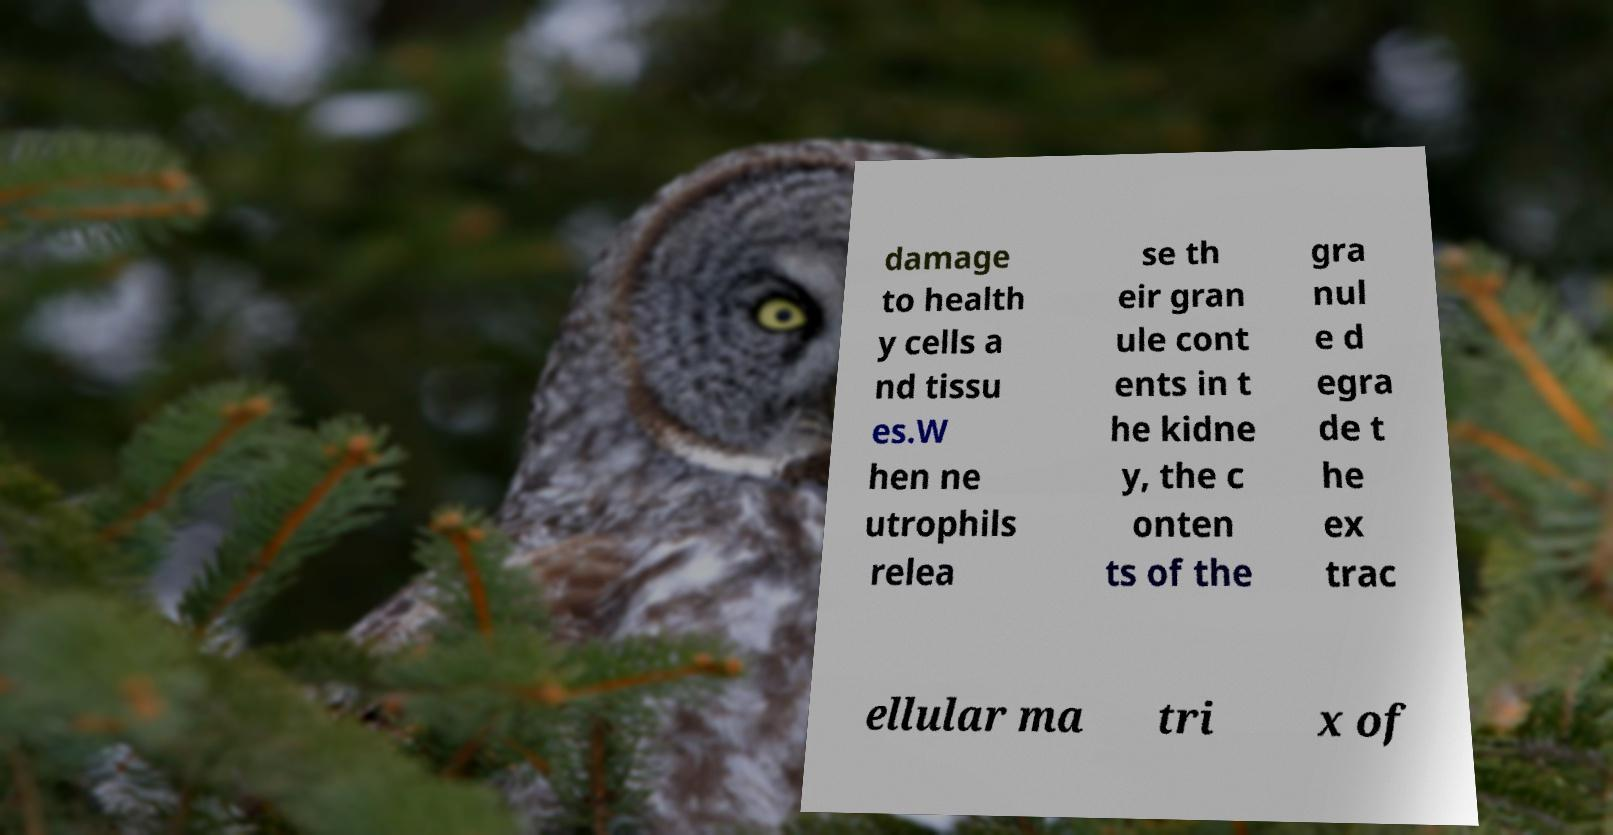Could you extract and type out the text from this image? damage to health y cells a nd tissu es.W hen ne utrophils relea se th eir gran ule cont ents in t he kidne y, the c onten ts of the gra nul e d egra de t he ex trac ellular ma tri x of 